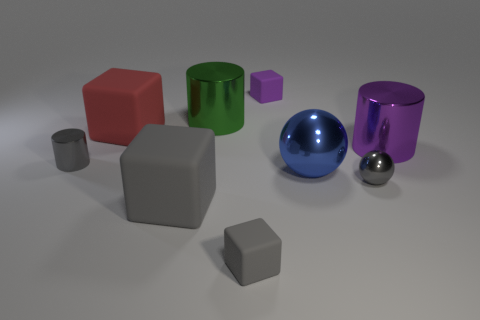Subtract 1 cubes. How many cubes are left? 3 Subtract all gray cubes. Subtract all blue cylinders. How many cubes are left? 2 Add 1 large red rubber objects. How many objects exist? 10 Subtract all spheres. How many objects are left? 7 Add 2 large green metal cylinders. How many large green metal cylinders are left? 3 Add 3 gray shiny cylinders. How many gray shiny cylinders exist? 4 Subtract 0 red cylinders. How many objects are left? 9 Subtract all small brown cylinders. Subtract all tiny matte things. How many objects are left? 7 